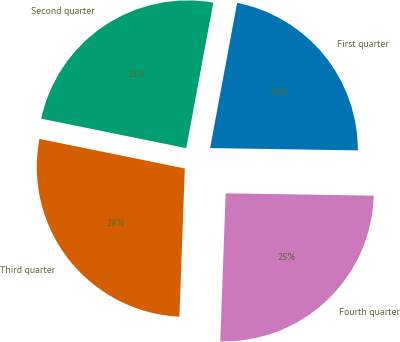Convert chart. <chart><loc_0><loc_0><loc_500><loc_500><pie_chart><fcel>First quarter<fcel>Second quarter<fcel>Third quarter<fcel>Fourth quarter<nl><fcel>22.32%<fcel>24.73%<fcel>27.61%<fcel>25.33%<nl></chart> 